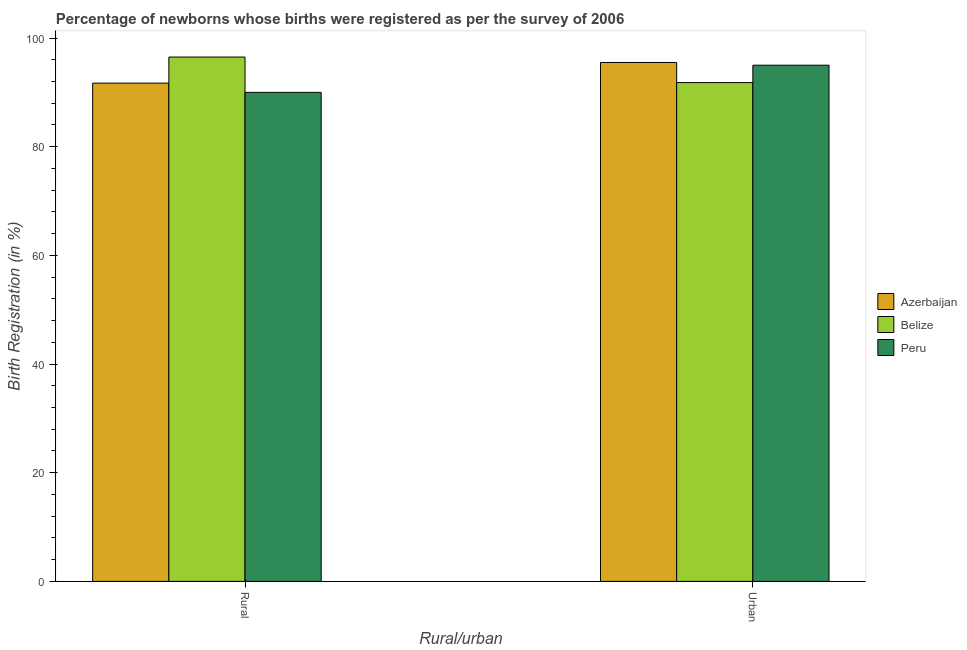How many groups of bars are there?
Your answer should be very brief. 2. How many bars are there on the 1st tick from the left?
Give a very brief answer. 3. How many bars are there on the 1st tick from the right?
Offer a very short reply. 3. What is the label of the 1st group of bars from the left?
Provide a succinct answer. Rural. What is the urban birth registration in Azerbaijan?
Provide a short and direct response. 95.5. Across all countries, what is the maximum rural birth registration?
Offer a terse response. 96.5. Across all countries, what is the minimum rural birth registration?
Offer a terse response. 90. In which country was the urban birth registration maximum?
Offer a very short reply. Azerbaijan. In which country was the urban birth registration minimum?
Your answer should be very brief. Belize. What is the total rural birth registration in the graph?
Give a very brief answer. 278.2. What is the difference between the rural birth registration in Belize and that in Azerbaijan?
Your response must be concise. 4.8. What is the difference between the urban birth registration in Belize and the rural birth registration in Peru?
Provide a succinct answer. 1.8. What is the average urban birth registration per country?
Make the answer very short. 94.1. What is the ratio of the urban birth registration in Azerbaijan to that in Peru?
Provide a succinct answer. 1.01. What does the 2nd bar from the left in Urban represents?
Keep it short and to the point. Belize. What does the 3rd bar from the right in Urban represents?
Your answer should be very brief. Azerbaijan. How many bars are there?
Give a very brief answer. 6. Are all the bars in the graph horizontal?
Provide a short and direct response. No. How many countries are there in the graph?
Provide a succinct answer. 3. What is the difference between two consecutive major ticks on the Y-axis?
Provide a short and direct response. 20. Are the values on the major ticks of Y-axis written in scientific E-notation?
Give a very brief answer. No. Does the graph contain any zero values?
Your answer should be very brief. No. What is the title of the graph?
Your response must be concise. Percentage of newborns whose births were registered as per the survey of 2006. What is the label or title of the X-axis?
Offer a very short reply. Rural/urban. What is the label or title of the Y-axis?
Your response must be concise. Birth Registration (in %). What is the Birth Registration (in %) of Azerbaijan in Rural?
Your answer should be very brief. 91.7. What is the Birth Registration (in %) in Belize in Rural?
Keep it short and to the point. 96.5. What is the Birth Registration (in %) in Peru in Rural?
Offer a very short reply. 90. What is the Birth Registration (in %) in Azerbaijan in Urban?
Ensure brevity in your answer.  95.5. What is the Birth Registration (in %) of Belize in Urban?
Offer a very short reply. 91.8. Across all Rural/urban, what is the maximum Birth Registration (in %) in Azerbaijan?
Keep it short and to the point. 95.5. Across all Rural/urban, what is the maximum Birth Registration (in %) in Belize?
Provide a short and direct response. 96.5. Across all Rural/urban, what is the minimum Birth Registration (in %) of Azerbaijan?
Your answer should be compact. 91.7. Across all Rural/urban, what is the minimum Birth Registration (in %) in Belize?
Provide a short and direct response. 91.8. What is the total Birth Registration (in %) in Azerbaijan in the graph?
Ensure brevity in your answer.  187.2. What is the total Birth Registration (in %) in Belize in the graph?
Make the answer very short. 188.3. What is the total Birth Registration (in %) in Peru in the graph?
Your response must be concise. 185. What is the difference between the Birth Registration (in %) in Peru in Rural and that in Urban?
Ensure brevity in your answer.  -5. What is the average Birth Registration (in %) of Azerbaijan per Rural/urban?
Your answer should be compact. 93.6. What is the average Birth Registration (in %) in Belize per Rural/urban?
Provide a short and direct response. 94.15. What is the average Birth Registration (in %) of Peru per Rural/urban?
Ensure brevity in your answer.  92.5. What is the difference between the Birth Registration (in %) in Azerbaijan and Birth Registration (in %) in Belize in Rural?
Offer a terse response. -4.8. What is the difference between the Birth Registration (in %) in Azerbaijan and Birth Registration (in %) in Peru in Rural?
Provide a succinct answer. 1.7. What is the difference between the Birth Registration (in %) in Belize and Birth Registration (in %) in Peru in Rural?
Provide a short and direct response. 6.5. What is the difference between the Birth Registration (in %) of Azerbaijan and Birth Registration (in %) of Belize in Urban?
Keep it short and to the point. 3.7. What is the difference between the Birth Registration (in %) of Belize and Birth Registration (in %) of Peru in Urban?
Give a very brief answer. -3.2. What is the ratio of the Birth Registration (in %) of Azerbaijan in Rural to that in Urban?
Keep it short and to the point. 0.96. What is the ratio of the Birth Registration (in %) in Belize in Rural to that in Urban?
Provide a short and direct response. 1.05. What is the difference between the highest and the second highest Birth Registration (in %) in Azerbaijan?
Ensure brevity in your answer.  3.8. What is the difference between the highest and the second highest Birth Registration (in %) in Belize?
Your response must be concise. 4.7. What is the difference between the highest and the lowest Birth Registration (in %) of Azerbaijan?
Make the answer very short. 3.8. 